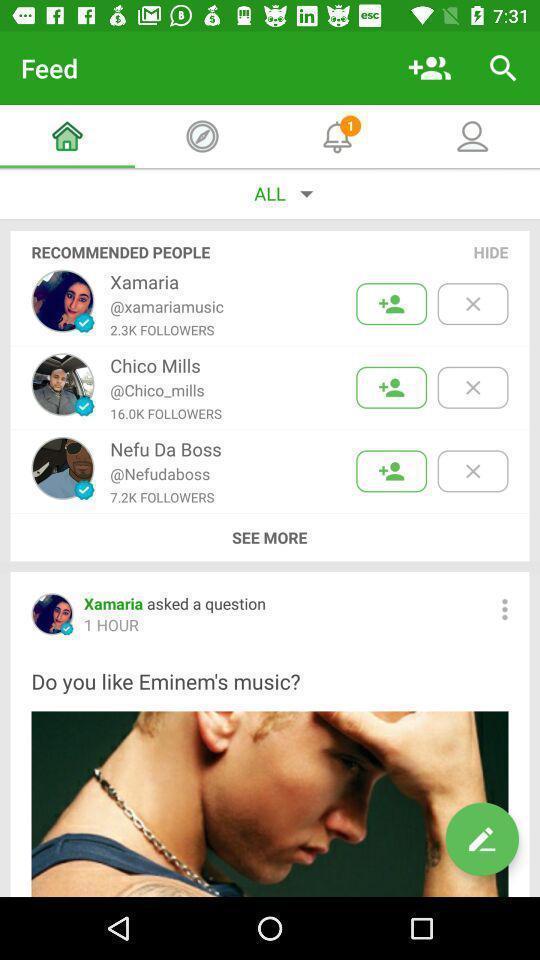Provide a detailed account of this screenshot. Page displaying various profiles in social application. 